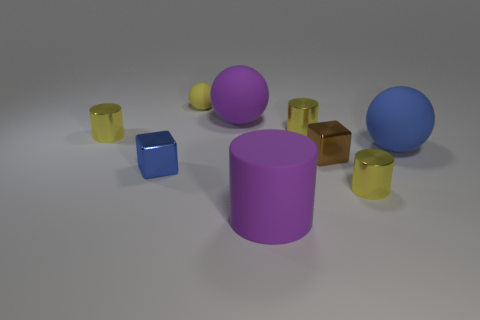Subtract all gray cubes. How many yellow cylinders are left? 3 Add 1 large blue rubber things. How many objects exist? 10 Subtract all balls. How many objects are left? 6 Add 3 big objects. How many big objects are left? 6 Add 2 yellow cylinders. How many yellow cylinders exist? 5 Subtract 0 gray balls. How many objects are left? 9 Subtract all gray metallic spheres. Subtract all big purple spheres. How many objects are left? 8 